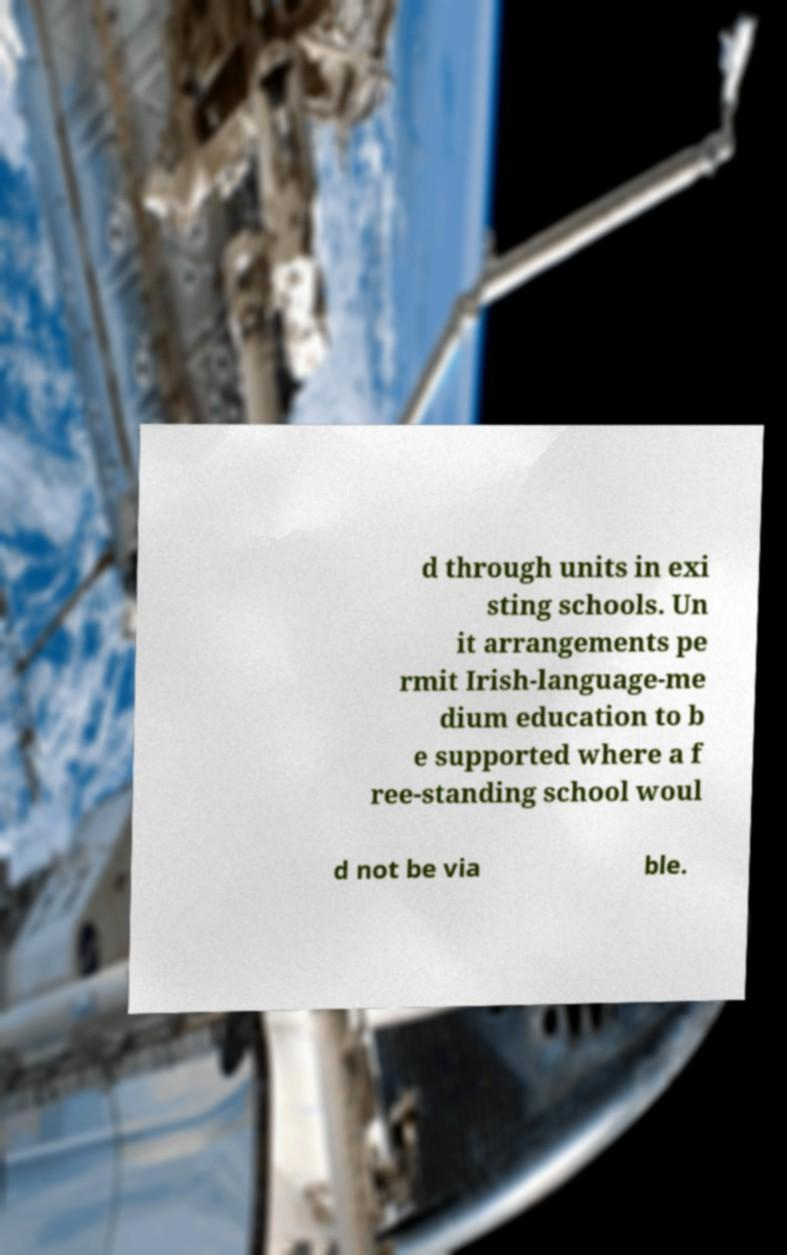I need the written content from this picture converted into text. Can you do that? d through units in exi sting schools. Un it arrangements pe rmit Irish-language-me dium education to b e supported where a f ree-standing school woul d not be via ble. 